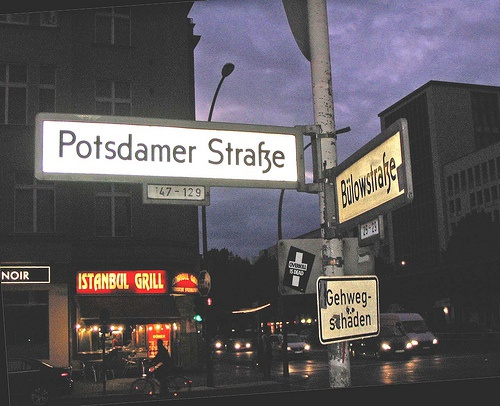Describe the objects in this image and their specific colors. I can see car in black, gray, and maroon tones, truck in black, gray, and white tones, car in black, gray, and white tones, bicycle in black tones, and car in black, gray, and ivory tones in this image. 